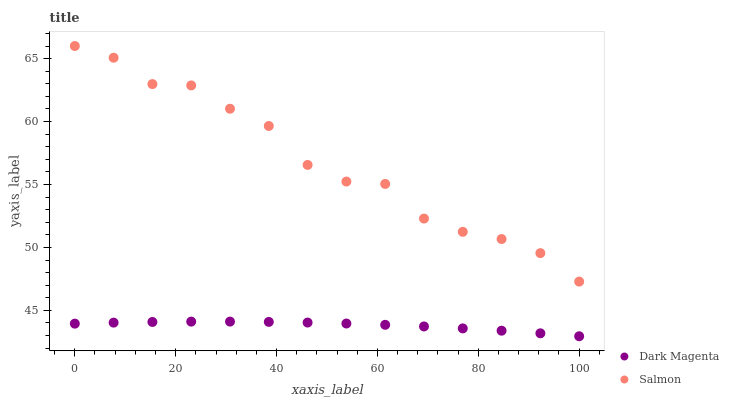Does Dark Magenta have the minimum area under the curve?
Answer yes or no. Yes. Does Salmon have the maximum area under the curve?
Answer yes or no. Yes. Does Dark Magenta have the maximum area under the curve?
Answer yes or no. No. Is Dark Magenta the smoothest?
Answer yes or no. Yes. Is Salmon the roughest?
Answer yes or no. Yes. Is Dark Magenta the roughest?
Answer yes or no. No. Does Dark Magenta have the lowest value?
Answer yes or no. Yes. Does Salmon have the highest value?
Answer yes or no. Yes. Does Dark Magenta have the highest value?
Answer yes or no. No. Is Dark Magenta less than Salmon?
Answer yes or no. Yes. Is Salmon greater than Dark Magenta?
Answer yes or no. Yes. Does Dark Magenta intersect Salmon?
Answer yes or no. No. 